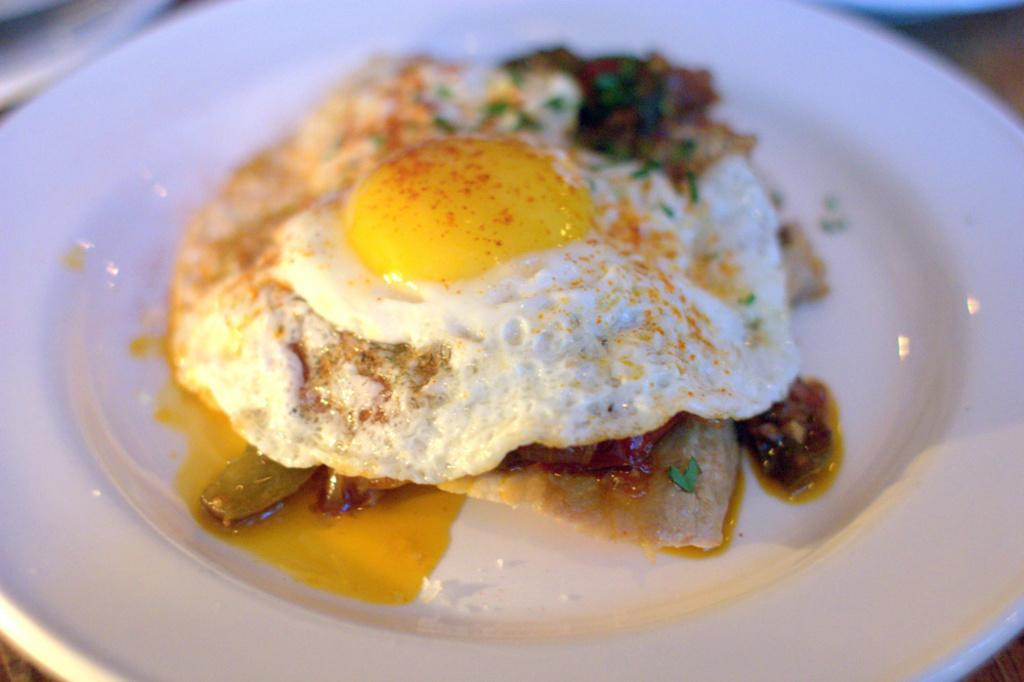What type of food item is present in the image? There is a food item in the image, which has a half-boiled omelette on it. How is the omelette presented in the image? The omelette is on a plate in the image. Can you describe the object in the left top corner of the image? Unfortunately, the facts provided do not give any information about the object in the left top corner of the image. What type of insect can be seen crawling on the celery in the image? There is no celery or insect present in the image. What type of trade is being conducted in the image? There is no indication of any trade being conducted in the image. 